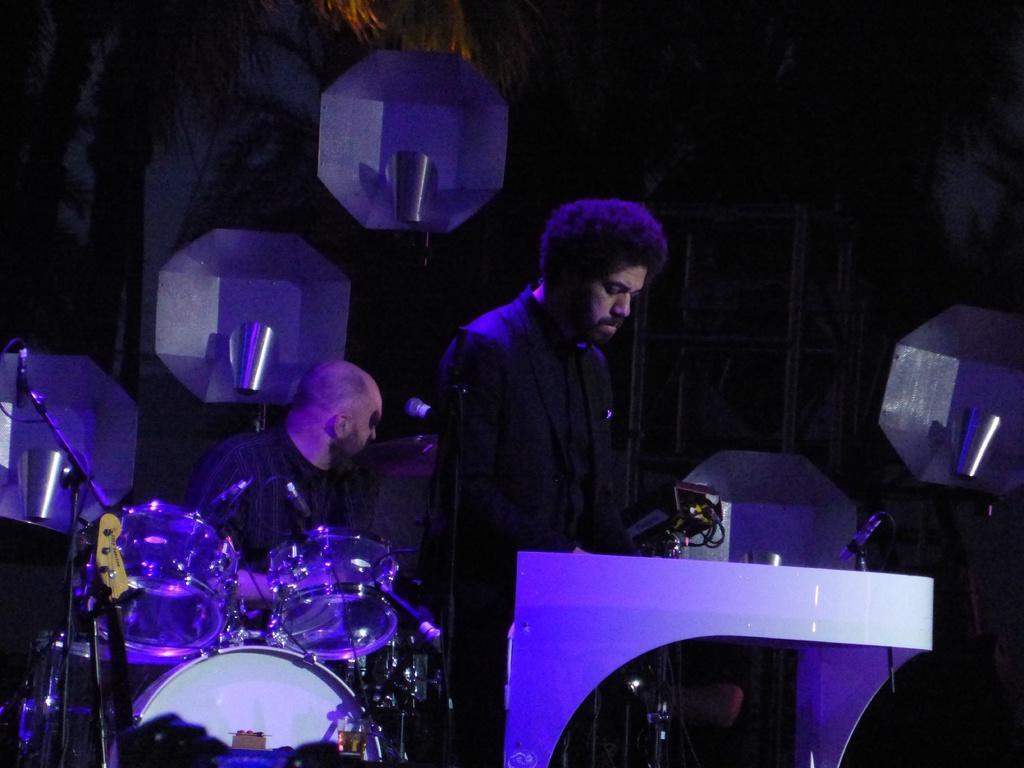Please provide a concise description of this image. In this image in the center there is one person who is standing and he is playing a piano, and also there is one mike and on the right side there is one person who is sitting and in front of him there are some drums. In the background there is a wall and some objects. 